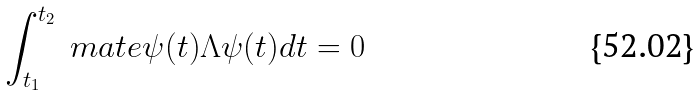<formula> <loc_0><loc_0><loc_500><loc_500>\int ^ { t _ { 2 } } _ { t _ { 1 } } \ m a t e { \psi ( t ) } { \Lambda } { \psi ( t ) } d t = 0</formula> 